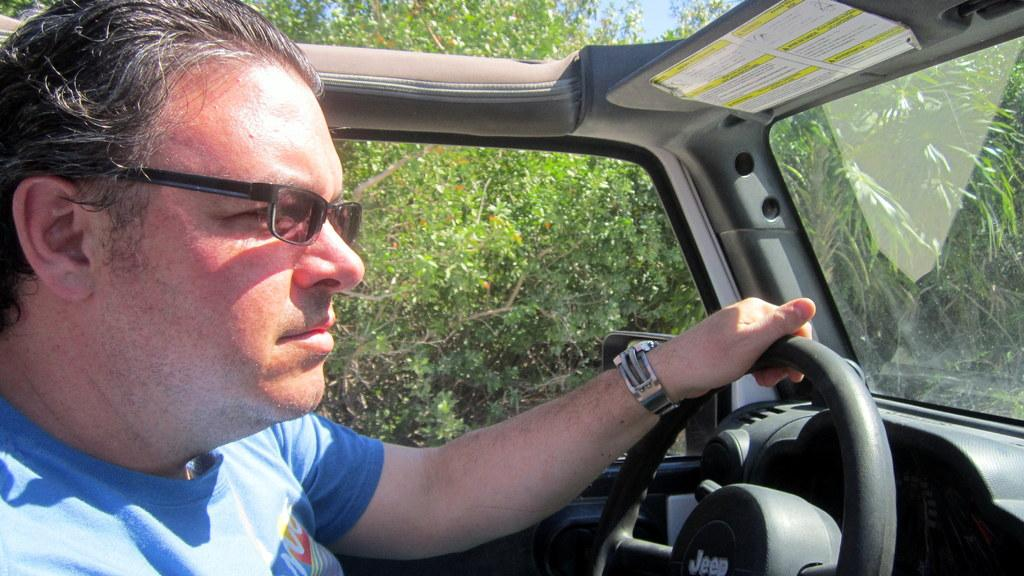What is the man in the car doing? The man is holding a steering wheel. What can be inferred about the man's vision from the image? The man is wearing spectacles, which suggests that he may need corrective lenses for his vision. What is the man wearing on his upper body? The man is wearing a blue t-shirt. What can be seen in the background of the image? There are trees visible in the background. How does the man use soap while driving in the image? There is no soap present in the image, and the man is not shown using soap while driving. 